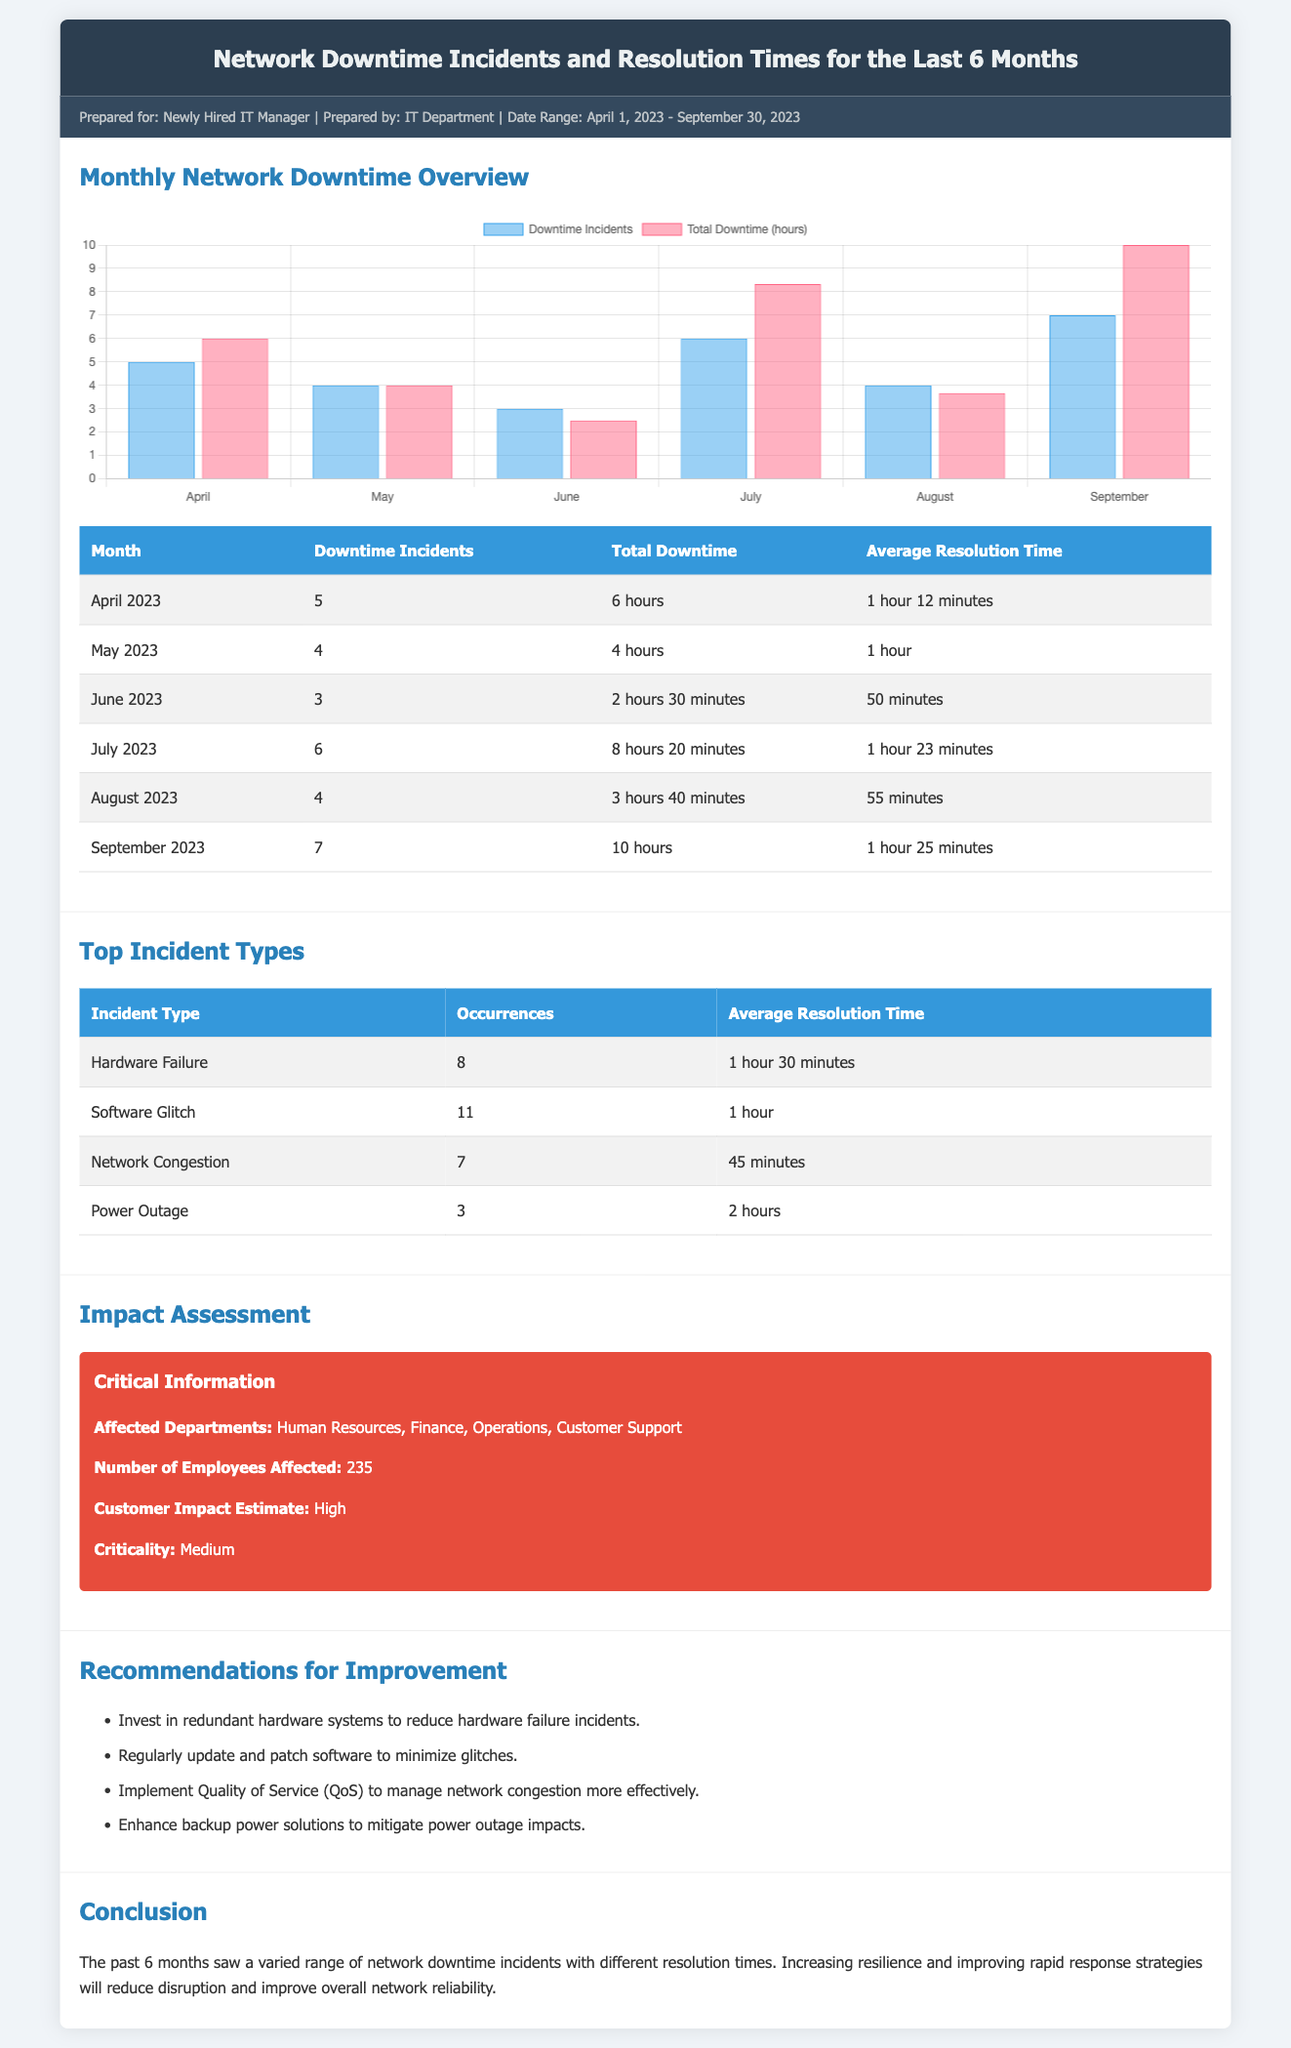What was the total downtime for June 2023? The total downtime for June 2023 is specifically stated in the table as 2 hours 30 minutes.
Answer: 2 hours 30 minutes How many downtime incidents were reported in May 2023? The number of downtime incidents for May 2023 is directly referenced in the table's corresponding row.
Answer: 4 What were the average resolution times for hardware failure incidents? The average resolution time for hardware failure is outlined in the "Top Incident Types" table under "Average Resolution Time."
Answer: 1 hour 30 minutes Which month had the highest number of downtime incidents? By comparing the monthly incident data, July 2023 shows the highest with 6 incidents.
Answer: July What is the total number of affected employees? The number of affected employees is clearly marked in the impact assessment section of the document.
Answer: 235 What recommendations were made to reduce hardware failure incidents? The document lists specific recommendations in the "Recommendations for Improvement" section, focusing on hardware systems.
Answer: Invest in redundant hardware systems Which incident type had the lowest occurrences? The "Top Incident Types" table provides each type's occurrence count, with power outage having the least at 3.
Answer: Power Outage What is the overall impact estimate for customers? The impact assessment section summarizes the customer impact estimate, which is presented alongside affected departments.
Answer: High What is the average resolution time for software glitches? The average resolution time for software glitches is found in the incident types table, indicating the average time taken to resolve such issues.
Answer: 1 hour 